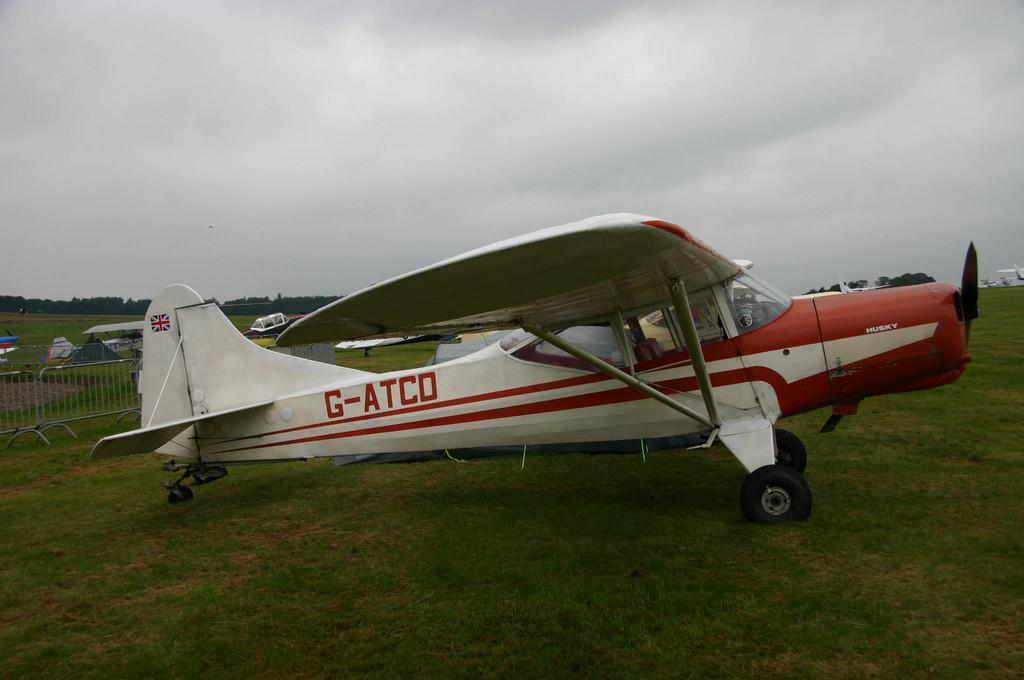<image>
Describe the image concisely. A single engine propeller plane with the tail number G-ATCO is parked in the grass. 